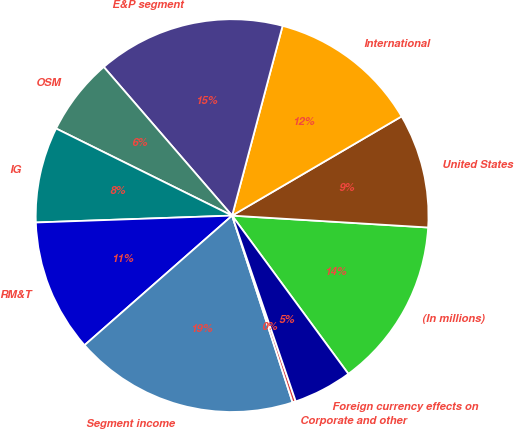Convert chart. <chart><loc_0><loc_0><loc_500><loc_500><pie_chart><fcel>(In millions)<fcel>United States<fcel>International<fcel>E&P segment<fcel>OSM<fcel>IG<fcel>RM&T<fcel>Segment income<fcel>Corporate and other<fcel>Foreign currency effects on<nl><fcel>13.95%<fcel>9.39%<fcel>12.43%<fcel>15.47%<fcel>6.35%<fcel>7.87%<fcel>10.91%<fcel>18.51%<fcel>0.27%<fcel>4.83%<nl></chart> 